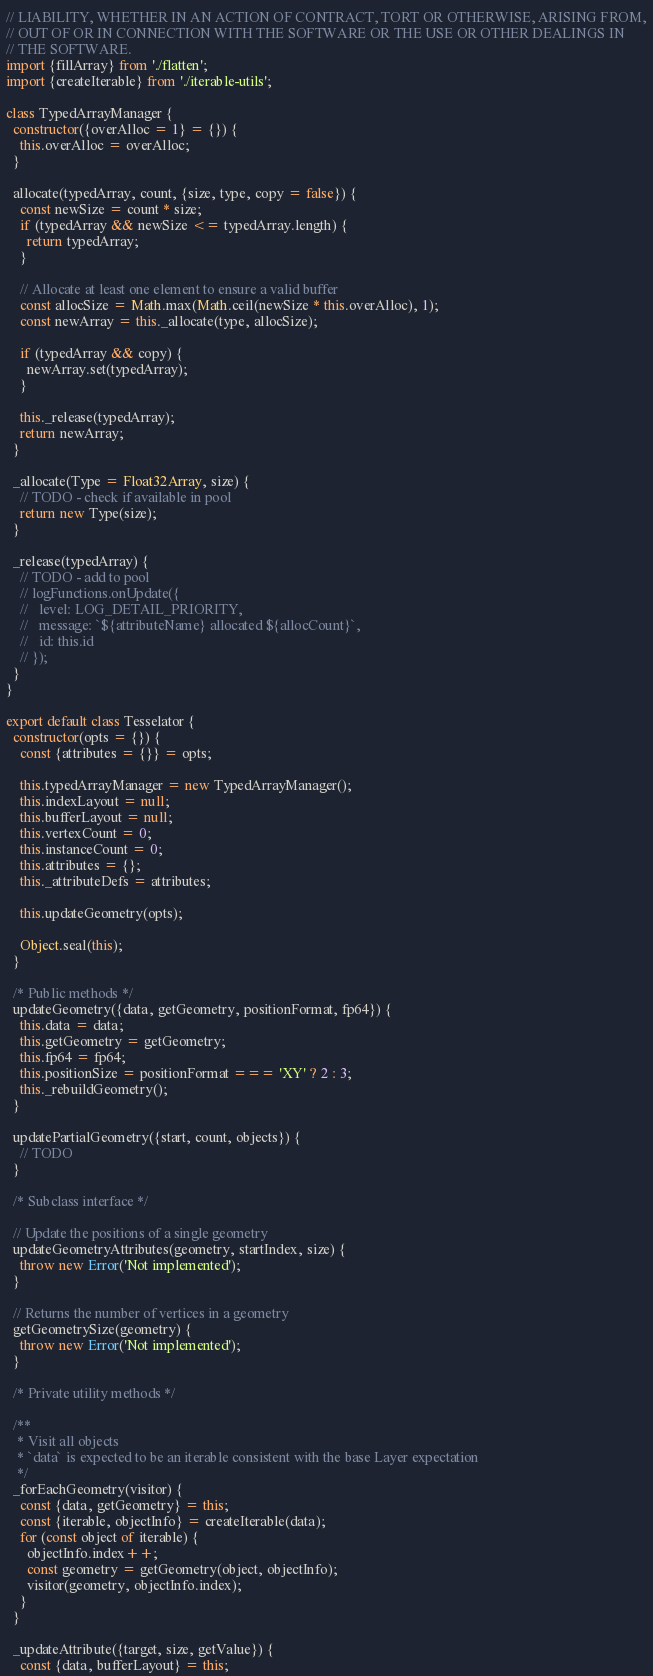Convert code to text. <code><loc_0><loc_0><loc_500><loc_500><_JavaScript_>// LIABILITY, WHETHER IN AN ACTION OF CONTRACT, TORT OR OTHERWISE, ARISING FROM,
// OUT OF OR IN CONNECTION WITH THE SOFTWARE OR THE USE OR OTHER DEALINGS IN
// THE SOFTWARE.
import {fillArray} from './flatten';
import {createIterable} from './iterable-utils';

class TypedArrayManager {
  constructor({overAlloc = 1} = {}) {
    this.overAlloc = overAlloc;
  }

  allocate(typedArray, count, {size, type, copy = false}) {
    const newSize = count * size;
    if (typedArray && newSize <= typedArray.length) {
      return typedArray;
    }

    // Allocate at least one element to ensure a valid buffer
    const allocSize = Math.max(Math.ceil(newSize * this.overAlloc), 1);
    const newArray = this._allocate(type, allocSize);

    if (typedArray && copy) {
      newArray.set(typedArray);
    }

    this._release(typedArray);
    return newArray;
  }

  _allocate(Type = Float32Array, size) {
    // TODO - check if available in pool
    return new Type(size);
  }

  _release(typedArray) {
    // TODO - add to pool
    // logFunctions.onUpdate({
    //   level: LOG_DETAIL_PRIORITY,
    //   message: `${attributeName} allocated ${allocCount}`,
    //   id: this.id
    // });
  }
}

export default class Tesselator {
  constructor(opts = {}) {
    const {attributes = {}} = opts;

    this.typedArrayManager = new TypedArrayManager();
    this.indexLayout = null;
    this.bufferLayout = null;
    this.vertexCount = 0;
    this.instanceCount = 0;
    this.attributes = {};
    this._attributeDefs = attributes;

    this.updateGeometry(opts);

    Object.seal(this);
  }

  /* Public methods */
  updateGeometry({data, getGeometry, positionFormat, fp64}) {
    this.data = data;
    this.getGeometry = getGeometry;
    this.fp64 = fp64;
    this.positionSize = positionFormat === 'XY' ? 2 : 3;
    this._rebuildGeometry();
  }

  updatePartialGeometry({start, count, objects}) {
    // TODO
  }

  /* Subclass interface */

  // Update the positions of a single geometry
  updateGeometryAttributes(geometry, startIndex, size) {
    throw new Error('Not implemented');
  }

  // Returns the number of vertices in a geometry
  getGeometrySize(geometry) {
    throw new Error('Not implemented');
  }

  /* Private utility methods */

  /**
   * Visit all objects
   * `data` is expected to be an iterable consistent with the base Layer expectation
   */
  _forEachGeometry(visitor) {
    const {data, getGeometry} = this;
    const {iterable, objectInfo} = createIterable(data);
    for (const object of iterable) {
      objectInfo.index++;
      const geometry = getGeometry(object, objectInfo);
      visitor(geometry, objectInfo.index);
    }
  }

  _updateAttribute({target, size, getValue}) {
    const {data, bufferLayout} = this;
</code> 